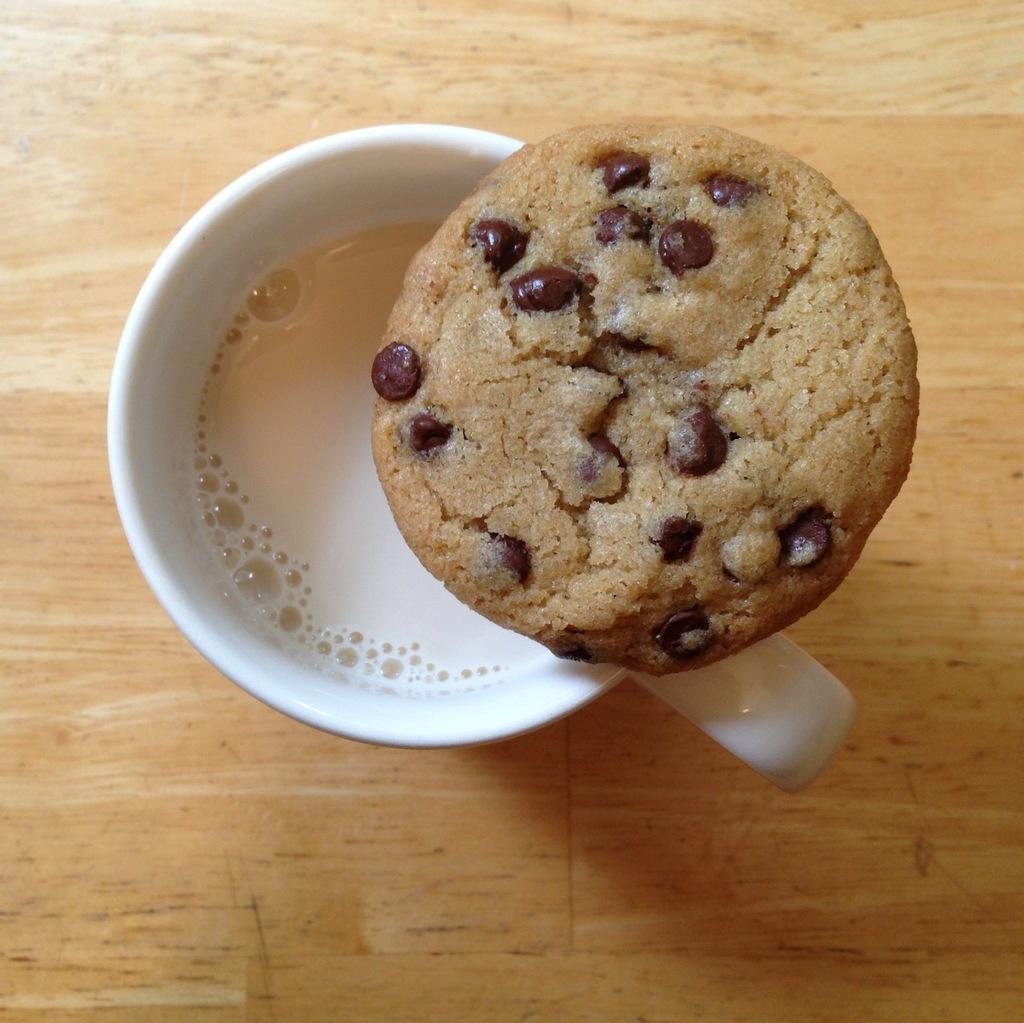Please provide a concise description of this image. In this picture there is a cup of tea in the center of the image and there is a cookie on it. 